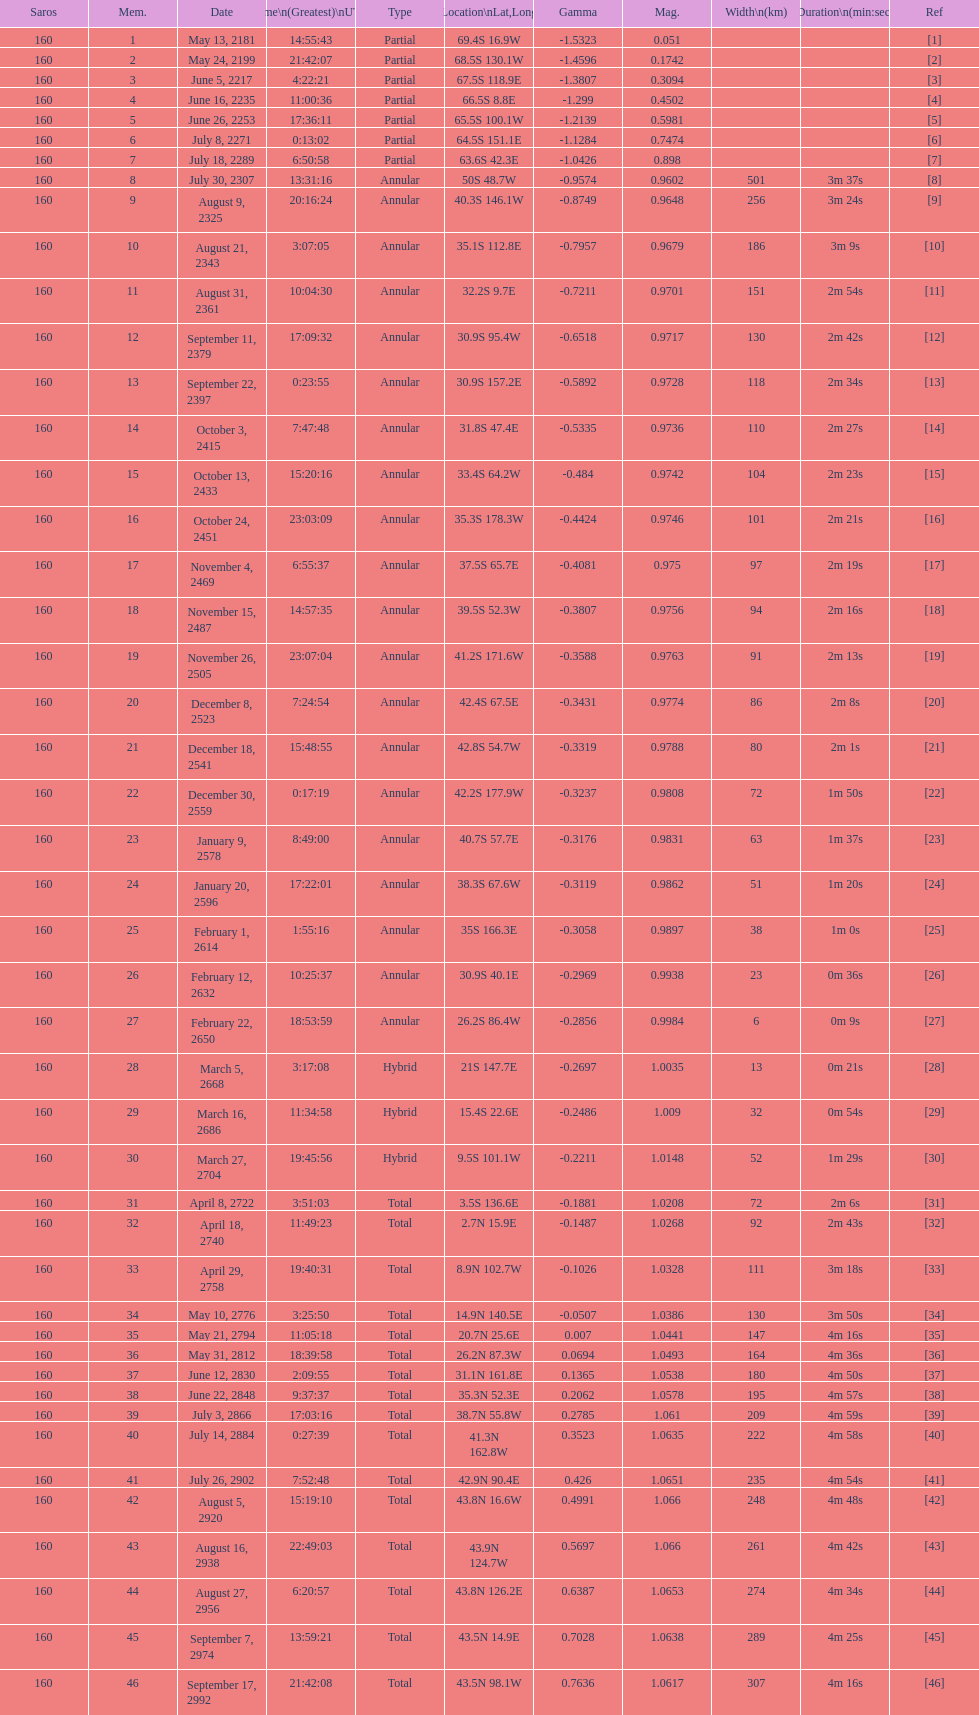When did the first solar saros with a magnitude of greater than 1.00 occur? March 5, 2668. 